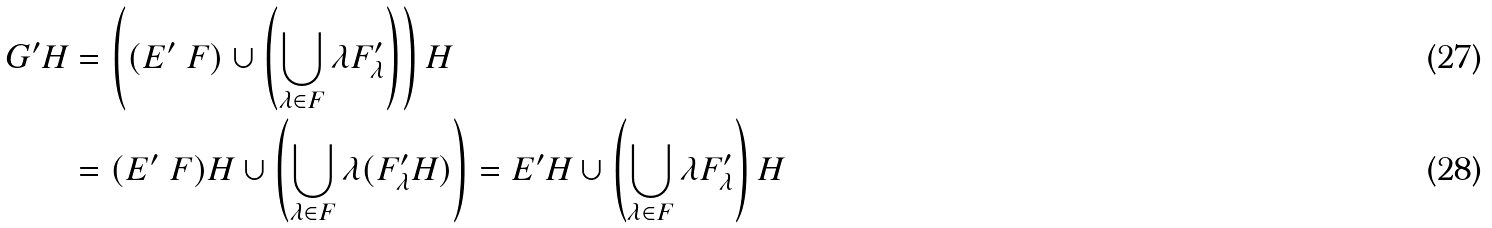Convert formula to latex. <formula><loc_0><loc_0><loc_500><loc_500>G ^ { \prime } H & = \left ( ( E ^ { \prime } \ F ) \cup \left ( \bigcup _ { \lambda \in F } \lambda F ^ { \prime } _ { \lambda } \right ) \right ) H \\ & = ( E ^ { \prime } \ F ) H \cup \left ( \bigcup _ { \lambda \in F } \lambda ( F ^ { \prime } _ { \lambda } H ) \right ) = E ^ { \prime } H \cup \left ( \bigcup _ { \lambda \in F } \lambda F ^ { \prime } _ { \lambda } \right ) H</formula> 